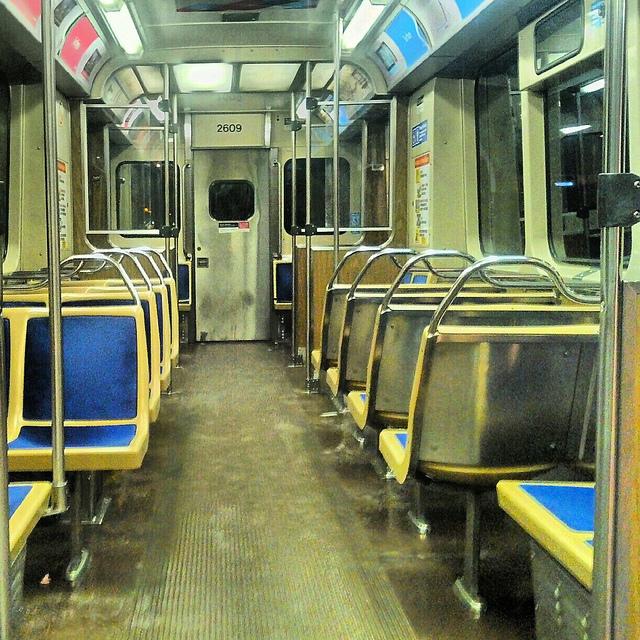What mode of transportation is this?
Write a very short answer. Subway. Does this need to be cleaned?
Answer briefly. Yes. How many seats are on the bus?
Answer briefly. 8. 